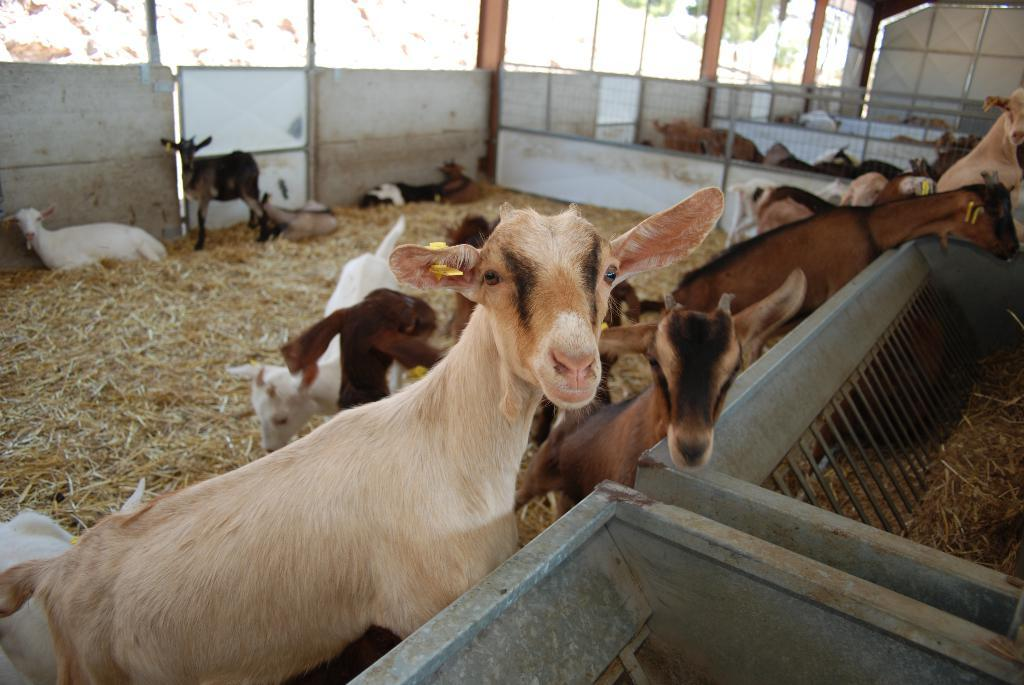What type of animals are inside the fence in the image? There are many goats inside the fence in the image. What is on the floor in the image? There is grass on the floor in the image. Can you describe the background of the image? In the background, there are more goats inside the fence. What type of beast is eating the cabbage in the image? There is no beast or cabbage present in the image. How many trees can be seen in the image? There are no trees visible in the image. 